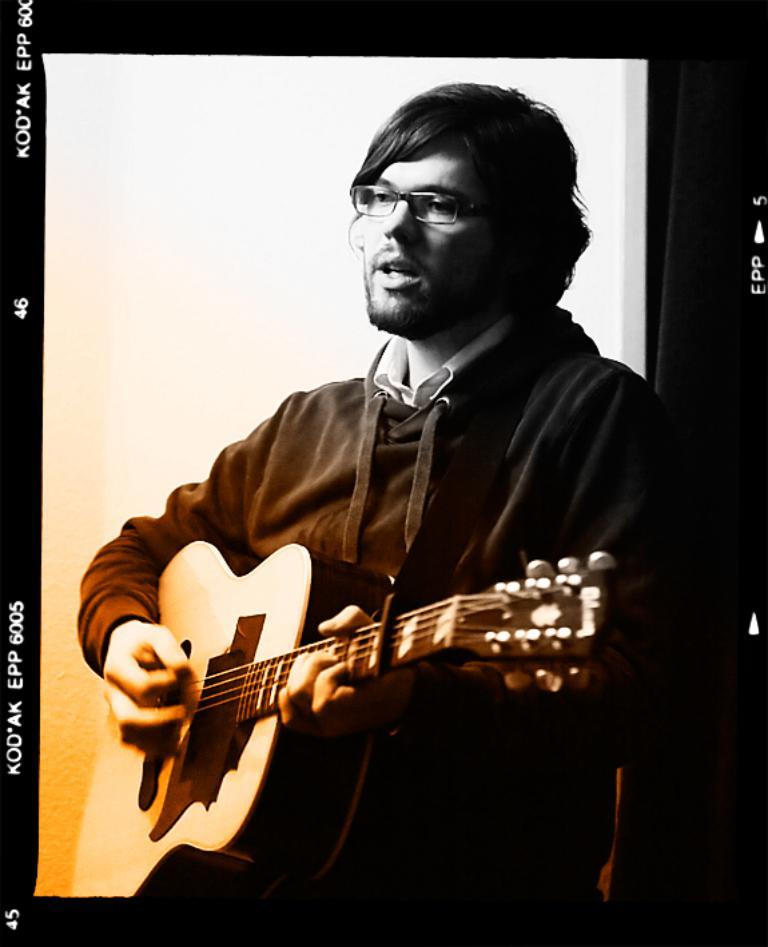What is the main subject of the image? The main subject of the image is a man. What is the man doing in the image? The man is standing, holding a guitar, and singing. What accessory is the man wearing in the image? The man is wearing spectacles. What type of sheet is the man using to play on the playground in the image? There is no sheet or playground present in the image; it features a man standing, holding a guitar, and singing while wearing spectacles. 